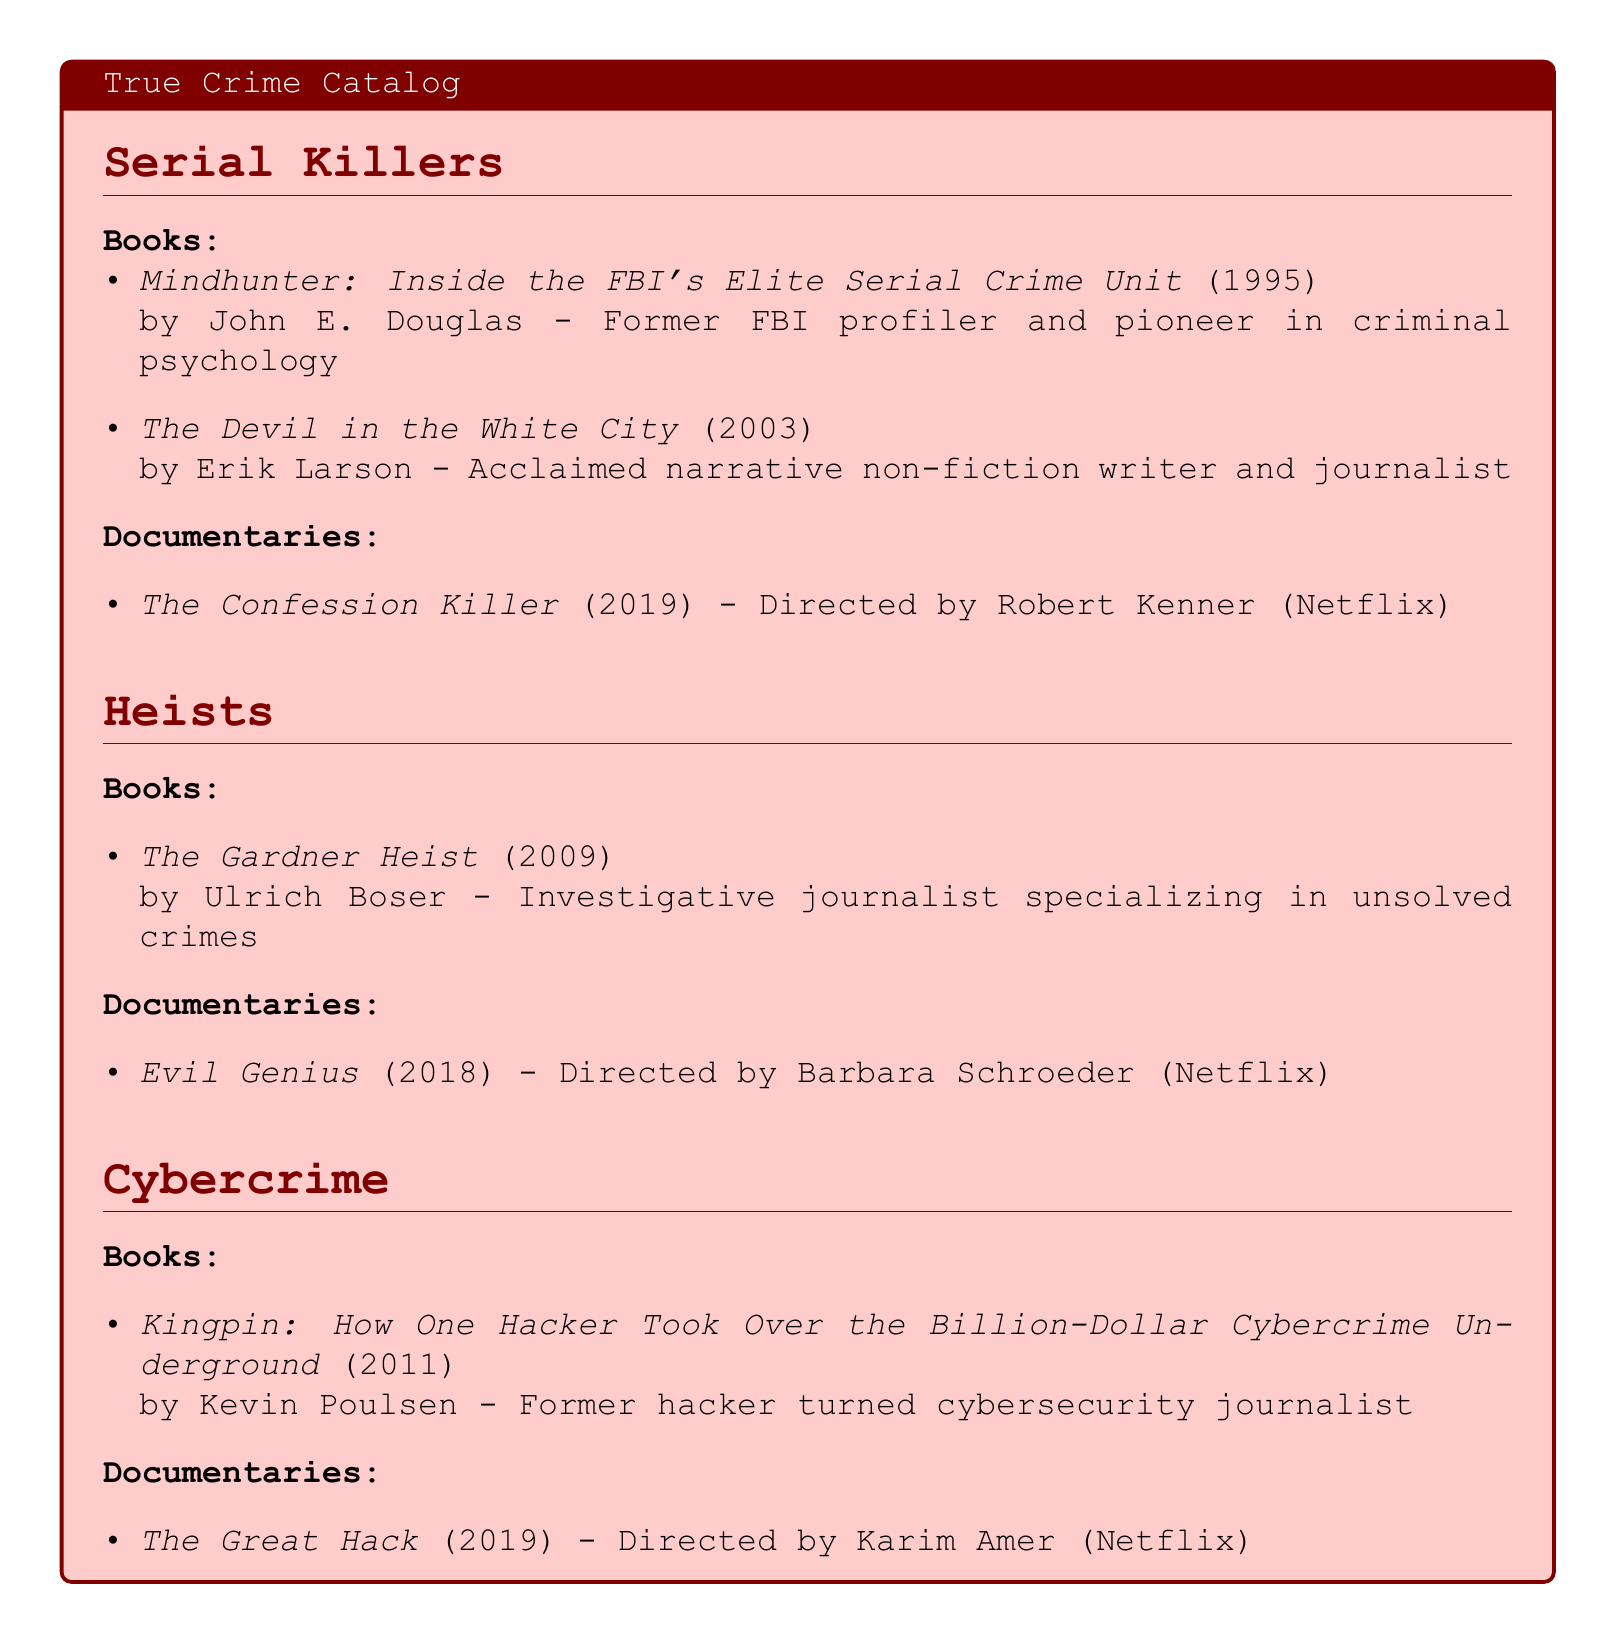What is the title of the book by John E. Douglas? The title of the book by John E. Douglas is mentioned in the "Serial Killers" section.
Answer: Mindhunter: Inside the FBI's Elite Serial Crime Unit Who is the author of "The Gardner Heist"? The author of "The Gardner Heist" is listed under the "Heists" section.
Answer: Ulrich Boser Which documentary is about cybercrime? The document specifies the documentaries under the "Cybercrime" section, asking for a particular example.
Answer: The Great Hack In what year was "The Devil in the White City" published? The publication year for "The Devil in the White City" can be found next to its title in the "Serial Killers" section.
Answer: 2003 How many books are listed under "Heists"? The number of books can be counted in the "Heists" section of the catalog.
Answer: 1 Who directed "Evil Genius"? The name of the director for "Evil Genius" is provided in the "Heists" section under documentaries.
Answer: Barbara Schroeder What genre does Erik Larson’s book belong to? The context of the book by Erik Larson in the "Serial Killers" section indicates its genre as narrative non-fiction.
Answer: Narrative non-fiction What is Kevin Poulsen known for? The document provides information about Kevin Poulsen's background in relation to his book in the "Cybercrime" section.
Answer: Former hacker turned cybersecurity journalist 